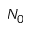<formula> <loc_0><loc_0><loc_500><loc_500>N _ { 0 }</formula> 